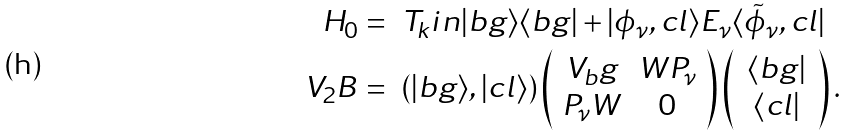<formula> <loc_0><loc_0><loc_500><loc_500>H _ { 0 } & = \ T _ { k } i n | b g \rangle \langle b g | + | \phi _ { \nu } , c l \rangle E _ { \nu } \langle \tilde { \phi } _ { \nu } , c l | \\ V _ { 2 } B & = \ ( | b g \rangle , | c l \rangle ) \left ( \begin{array} { c c } V _ { b } g & W P _ { \nu } \\ P _ { \nu } W & 0 \end{array} \right ) \left ( \, \begin{array} { c } \langle b g | \\ \langle c l | \end{array} \, \right ) .</formula> 